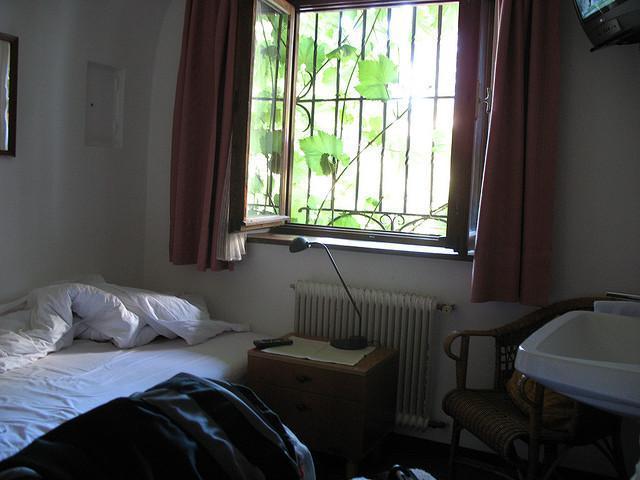How many light sources are there?
Give a very brief answer. 2. How many beds are in the room?
Give a very brief answer. 1. How many beds can be seen?
Give a very brief answer. 1. 